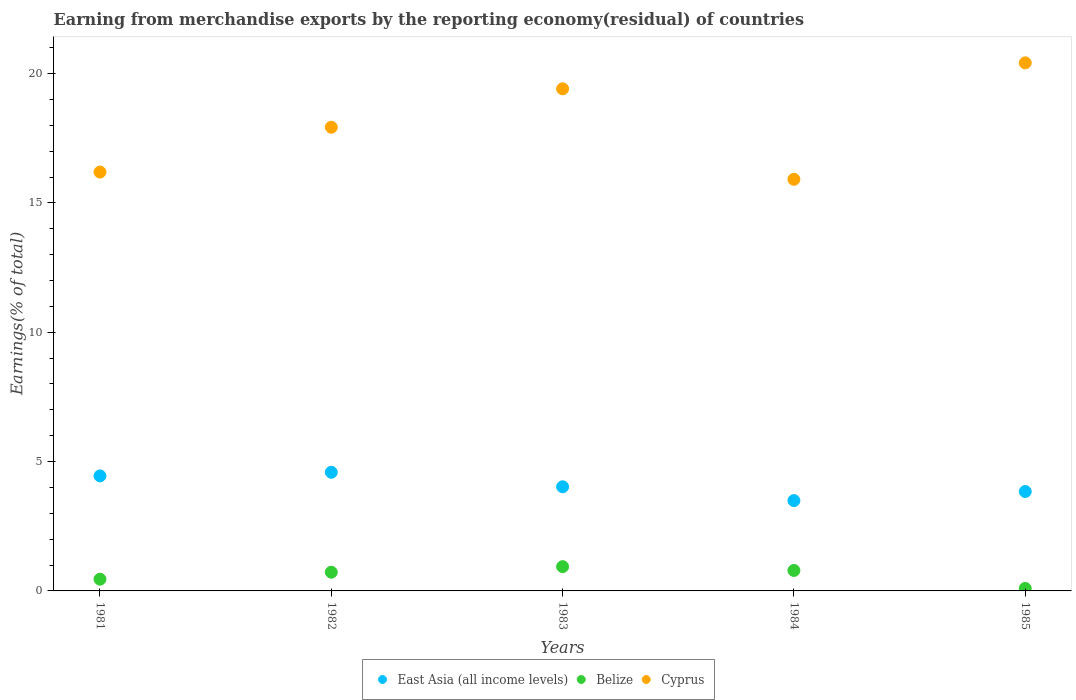How many different coloured dotlines are there?
Ensure brevity in your answer.  3. What is the percentage of amount earned from merchandise exports in East Asia (all income levels) in 1981?
Your answer should be compact. 4.45. Across all years, what is the maximum percentage of amount earned from merchandise exports in East Asia (all income levels)?
Offer a very short reply. 4.59. Across all years, what is the minimum percentage of amount earned from merchandise exports in East Asia (all income levels)?
Keep it short and to the point. 3.49. What is the total percentage of amount earned from merchandise exports in East Asia (all income levels) in the graph?
Give a very brief answer. 20.39. What is the difference between the percentage of amount earned from merchandise exports in Belize in 1981 and that in 1984?
Provide a short and direct response. -0.34. What is the difference between the percentage of amount earned from merchandise exports in East Asia (all income levels) in 1981 and the percentage of amount earned from merchandise exports in Cyprus in 1982?
Keep it short and to the point. -13.48. What is the average percentage of amount earned from merchandise exports in East Asia (all income levels) per year?
Give a very brief answer. 4.08. In the year 1985, what is the difference between the percentage of amount earned from merchandise exports in Belize and percentage of amount earned from merchandise exports in East Asia (all income levels)?
Keep it short and to the point. -3.75. In how many years, is the percentage of amount earned from merchandise exports in Belize greater than 16 %?
Offer a very short reply. 0. What is the ratio of the percentage of amount earned from merchandise exports in East Asia (all income levels) in 1982 to that in 1984?
Ensure brevity in your answer.  1.31. What is the difference between the highest and the second highest percentage of amount earned from merchandise exports in Belize?
Provide a short and direct response. 0.15. What is the difference between the highest and the lowest percentage of amount earned from merchandise exports in Cyprus?
Ensure brevity in your answer.  4.5. Is the sum of the percentage of amount earned from merchandise exports in East Asia (all income levels) in 1982 and 1985 greater than the maximum percentage of amount earned from merchandise exports in Cyprus across all years?
Offer a terse response. No. Is the percentage of amount earned from merchandise exports in East Asia (all income levels) strictly greater than the percentage of amount earned from merchandise exports in Belize over the years?
Your answer should be very brief. Yes. How many dotlines are there?
Your answer should be compact. 3. How many years are there in the graph?
Provide a succinct answer. 5. What is the difference between two consecutive major ticks on the Y-axis?
Offer a terse response. 5. Does the graph contain any zero values?
Your answer should be compact. No. Where does the legend appear in the graph?
Your response must be concise. Bottom center. How many legend labels are there?
Your answer should be compact. 3. How are the legend labels stacked?
Ensure brevity in your answer.  Horizontal. What is the title of the graph?
Provide a succinct answer. Earning from merchandise exports by the reporting economy(residual) of countries. Does "Peru" appear as one of the legend labels in the graph?
Make the answer very short. No. What is the label or title of the Y-axis?
Make the answer very short. Earnings(% of total). What is the Earnings(% of total) of East Asia (all income levels) in 1981?
Provide a succinct answer. 4.45. What is the Earnings(% of total) of Belize in 1981?
Your answer should be very brief. 0.45. What is the Earnings(% of total) of Cyprus in 1981?
Your answer should be very brief. 16.19. What is the Earnings(% of total) of East Asia (all income levels) in 1982?
Your response must be concise. 4.59. What is the Earnings(% of total) in Belize in 1982?
Your response must be concise. 0.72. What is the Earnings(% of total) in Cyprus in 1982?
Provide a succinct answer. 17.93. What is the Earnings(% of total) in East Asia (all income levels) in 1983?
Make the answer very short. 4.03. What is the Earnings(% of total) in Belize in 1983?
Make the answer very short. 0.94. What is the Earnings(% of total) in Cyprus in 1983?
Give a very brief answer. 19.41. What is the Earnings(% of total) in East Asia (all income levels) in 1984?
Provide a short and direct response. 3.49. What is the Earnings(% of total) of Belize in 1984?
Keep it short and to the point. 0.79. What is the Earnings(% of total) in Cyprus in 1984?
Offer a terse response. 15.91. What is the Earnings(% of total) of East Asia (all income levels) in 1985?
Provide a succinct answer. 3.84. What is the Earnings(% of total) in Belize in 1985?
Ensure brevity in your answer.  0.1. What is the Earnings(% of total) in Cyprus in 1985?
Your response must be concise. 20.41. Across all years, what is the maximum Earnings(% of total) of East Asia (all income levels)?
Provide a succinct answer. 4.59. Across all years, what is the maximum Earnings(% of total) of Belize?
Make the answer very short. 0.94. Across all years, what is the maximum Earnings(% of total) in Cyprus?
Keep it short and to the point. 20.41. Across all years, what is the minimum Earnings(% of total) in East Asia (all income levels)?
Your response must be concise. 3.49. Across all years, what is the minimum Earnings(% of total) of Belize?
Offer a terse response. 0.1. Across all years, what is the minimum Earnings(% of total) in Cyprus?
Provide a succinct answer. 15.91. What is the total Earnings(% of total) of East Asia (all income levels) in the graph?
Give a very brief answer. 20.39. What is the total Earnings(% of total) in Belize in the graph?
Your answer should be very brief. 3. What is the total Earnings(% of total) of Cyprus in the graph?
Keep it short and to the point. 89.86. What is the difference between the Earnings(% of total) in East Asia (all income levels) in 1981 and that in 1982?
Give a very brief answer. -0.14. What is the difference between the Earnings(% of total) of Belize in 1981 and that in 1982?
Provide a short and direct response. -0.27. What is the difference between the Earnings(% of total) in Cyprus in 1981 and that in 1982?
Your answer should be very brief. -1.73. What is the difference between the Earnings(% of total) in East Asia (all income levels) in 1981 and that in 1983?
Make the answer very short. 0.42. What is the difference between the Earnings(% of total) of Belize in 1981 and that in 1983?
Your answer should be compact. -0.48. What is the difference between the Earnings(% of total) in Cyprus in 1981 and that in 1983?
Provide a succinct answer. -3.22. What is the difference between the Earnings(% of total) of East Asia (all income levels) in 1981 and that in 1984?
Your response must be concise. 0.96. What is the difference between the Earnings(% of total) in Belize in 1981 and that in 1984?
Your answer should be compact. -0.34. What is the difference between the Earnings(% of total) in Cyprus in 1981 and that in 1984?
Your answer should be compact. 0.28. What is the difference between the Earnings(% of total) of East Asia (all income levels) in 1981 and that in 1985?
Your answer should be very brief. 0.6. What is the difference between the Earnings(% of total) of Belize in 1981 and that in 1985?
Provide a short and direct response. 0.36. What is the difference between the Earnings(% of total) of Cyprus in 1981 and that in 1985?
Offer a terse response. -4.22. What is the difference between the Earnings(% of total) in East Asia (all income levels) in 1982 and that in 1983?
Your response must be concise. 0.56. What is the difference between the Earnings(% of total) in Belize in 1982 and that in 1983?
Provide a succinct answer. -0.21. What is the difference between the Earnings(% of total) of Cyprus in 1982 and that in 1983?
Your answer should be very brief. -1.49. What is the difference between the Earnings(% of total) in East Asia (all income levels) in 1982 and that in 1984?
Your response must be concise. 1.09. What is the difference between the Earnings(% of total) of Belize in 1982 and that in 1984?
Give a very brief answer. -0.07. What is the difference between the Earnings(% of total) in Cyprus in 1982 and that in 1984?
Give a very brief answer. 2.01. What is the difference between the Earnings(% of total) in East Asia (all income levels) in 1982 and that in 1985?
Ensure brevity in your answer.  0.74. What is the difference between the Earnings(% of total) of Belize in 1982 and that in 1985?
Provide a short and direct response. 0.63. What is the difference between the Earnings(% of total) of Cyprus in 1982 and that in 1985?
Give a very brief answer. -2.49. What is the difference between the Earnings(% of total) in East Asia (all income levels) in 1983 and that in 1984?
Provide a succinct answer. 0.53. What is the difference between the Earnings(% of total) in Belize in 1983 and that in 1984?
Your answer should be compact. 0.15. What is the difference between the Earnings(% of total) of Cyprus in 1983 and that in 1984?
Provide a succinct answer. 3.5. What is the difference between the Earnings(% of total) in East Asia (all income levels) in 1983 and that in 1985?
Ensure brevity in your answer.  0.18. What is the difference between the Earnings(% of total) of Belize in 1983 and that in 1985?
Your answer should be very brief. 0.84. What is the difference between the Earnings(% of total) in Cyprus in 1983 and that in 1985?
Offer a terse response. -1. What is the difference between the Earnings(% of total) of East Asia (all income levels) in 1984 and that in 1985?
Provide a succinct answer. -0.35. What is the difference between the Earnings(% of total) of Belize in 1984 and that in 1985?
Offer a terse response. 0.69. What is the difference between the Earnings(% of total) in Cyprus in 1984 and that in 1985?
Offer a very short reply. -4.5. What is the difference between the Earnings(% of total) in East Asia (all income levels) in 1981 and the Earnings(% of total) in Belize in 1982?
Provide a succinct answer. 3.72. What is the difference between the Earnings(% of total) in East Asia (all income levels) in 1981 and the Earnings(% of total) in Cyprus in 1982?
Your response must be concise. -13.48. What is the difference between the Earnings(% of total) in Belize in 1981 and the Earnings(% of total) in Cyprus in 1982?
Provide a short and direct response. -17.47. What is the difference between the Earnings(% of total) of East Asia (all income levels) in 1981 and the Earnings(% of total) of Belize in 1983?
Give a very brief answer. 3.51. What is the difference between the Earnings(% of total) of East Asia (all income levels) in 1981 and the Earnings(% of total) of Cyprus in 1983?
Your response must be concise. -14.96. What is the difference between the Earnings(% of total) in Belize in 1981 and the Earnings(% of total) in Cyprus in 1983?
Your answer should be very brief. -18.96. What is the difference between the Earnings(% of total) in East Asia (all income levels) in 1981 and the Earnings(% of total) in Belize in 1984?
Offer a terse response. 3.66. What is the difference between the Earnings(% of total) of East Asia (all income levels) in 1981 and the Earnings(% of total) of Cyprus in 1984?
Give a very brief answer. -11.47. What is the difference between the Earnings(% of total) in Belize in 1981 and the Earnings(% of total) in Cyprus in 1984?
Offer a very short reply. -15.46. What is the difference between the Earnings(% of total) of East Asia (all income levels) in 1981 and the Earnings(% of total) of Belize in 1985?
Your answer should be very brief. 4.35. What is the difference between the Earnings(% of total) of East Asia (all income levels) in 1981 and the Earnings(% of total) of Cyprus in 1985?
Your answer should be very brief. -15.97. What is the difference between the Earnings(% of total) in Belize in 1981 and the Earnings(% of total) in Cyprus in 1985?
Give a very brief answer. -19.96. What is the difference between the Earnings(% of total) of East Asia (all income levels) in 1982 and the Earnings(% of total) of Belize in 1983?
Offer a very short reply. 3.65. What is the difference between the Earnings(% of total) in East Asia (all income levels) in 1982 and the Earnings(% of total) in Cyprus in 1983?
Offer a very short reply. -14.82. What is the difference between the Earnings(% of total) in Belize in 1982 and the Earnings(% of total) in Cyprus in 1983?
Your response must be concise. -18.69. What is the difference between the Earnings(% of total) of East Asia (all income levels) in 1982 and the Earnings(% of total) of Belize in 1984?
Make the answer very short. 3.8. What is the difference between the Earnings(% of total) in East Asia (all income levels) in 1982 and the Earnings(% of total) in Cyprus in 1984?
Offer a terse response. -11.33. What is the difference between the Earnings(% of total) of Belize in 1982 and the Earnings(% of total) of Cyprus in 1984?
Provide a succinct answer. -15.19. What is the difference between the Earnings(% of total) in East Asia (all income levels) in 1982 and the Earnings(% of total) in Belize in 1985?
Offer a very short reply. 4.49. What is the difference between the Earnings(% of total) in East Asia (all income levels) in 1982 and the Earnings(% of total) in Cyprus in 1985?
Ensure brevity in your answer.  -15.83. What is the difference between the Earnings(% of total) of Belize in 1982 and the Earnings(% of total) of Cyprus in 1985?
Keep it short and to the point. -19.69. What is the difference between the Earnings(% of total) of East Asia (all income levels) in 1983 and the Earnings(% of total) of Belize in 1984?
Offer a terse response. 3.23. What is the difference between the Earnings(% of total) in East Asia (all income levels) in 1983 and the Earnings(% of total) in Cyprus in 1984?
Your answer should be very brief. -11.89. What is the difference between the Earnings(% of total) of Belize in 1983 and the Earnings(% of total) of Cyprus in 1984?
Your answer should be compact. -14.97. What is the difference between the Earnings(% of total) in East Asia (all income levels) in 1983 and the Earnings(% of total) in Belize in 1985?
Provide a succinct answer. 3.93. What is the difference between the Earnings(% of total) of East Asia (all income levels) in 1983 and the Earnings(% of total) of Cyprus in 1985?
Your response must be concise. -16.39. What is the difference between the Earnings(% of total) in Belize in 1983 and the Earnings(% of total) in Cyprus in 1985?
Your answer should be very brief. -19.48. What is the difference between the Earnings(% of total) in East Asia (all income levels) in 1984 and the Earnings(% of total) in Belize in 1985?
Your response must be concise. 3.39. What is the difference between the Earnings(% of total) of East Asia (all income levels) in 1984 and the Earnings(% of total) of Cyprus in 1985?
Keep it short and to the point. -16.92. What is the difference between the Earnings(% of total) of Belize in 1984 and the Earnings(% of total) of Cyprus in 1985?
Your response must be concise. -19.62. What is the average Earnings(% of total) of East Asia (all income levels) per year?
Keep it short and to the point. 4.08. What is the average Earnings(% of total) in Belize per year?
Make the answer very short. 0.6. What is the average Earnings(% of total) of Cyprus per year?
Provide a short and direct response. 17.97. In the year 1981, what is the difference between the Earnings(% of total) of East Asia (all income levels) and Earnings(% of total) of Belize?
Provide a succinct answer. 3.99. In the year 1981, what is the difference between the Earnings(% of total) of East Asia (all income levels) and Earnings(% of total) of Cyprus?
Ensure brevity in your answer.  -11.75. In the year 1981, what is the difference between the Earnings(% of total) in Belize and Earnings(% of total) in Cyprus?
Make the answer very short. -15.74. In the year 1982, what is the difference between the Earnings(% of total) of East Asia (all income levels) and Earnings(% of total) of Belize?
Offer a very short reply. 3.86. In the year 1982, what is the difference between the Earnings(% of total) of East Asia (all income levels) and Earnings(% of total) of Cyprus?
Provide a succinct answer. -13.34. In the year 1982, what is the difference between the Earnings(% of total) of Belize and Earnings(% of total) of Cyprus?
Give a very brief answer. -17.2. In the year 1983, what is the difference between the Earnings(% of total) of East Asia (all income levels) and Earnings(% of total) of Belize?
Ensure brevity in your answer.  3.09. In the year 1983, what is the difference between the Earnings(% of total) in East Asia (all income levels) and Earnings(% of total) in Cyprus?
Provide a succinct answer. -15.39. In the year 1983, what is the difference between the Earnings(% of total) of Belize and Earnings(% of total) of Cyprus?
Your answer should be compact. -18.47. In the year 1984, what is the difference between the Earnings(% of total) of East Asia (all income levels) and Earnings(% of total) of Belize?
Ensure brevity in your answer.  2.7. In the year 1984, what is the difference between the Earnings(% of total) in East Asia (all income levels) and Earnings(% of total) in Cyprus?
Provide a succinct answer. -12.42. In the year 1984, what is the difference between the Earnings(% of total) of Belize and Earnings(% of total) of Cyprus?
Offer a terse response. -15.12. In the year 1985, what is the difference between the Earnings(% of total) of East Asia (all income levels) and Earnings(% of total) of Belize?
Keep it short and to the point. 3.75. In the year 1985, what is the difference between the Earnings(% of total) in East Asia (all income levels) and Earnings(% of total) in Cyprus?
Offer a very short reply. -16.57. In the year 1985, what is the difference between the Earnings(% of total) of Belize and Earnings(% of total) of Cyprus?
Keep it short and to the point. -20.32. What is the ratio of the Earnings(% of total) of East Asia (all income levels) in 1981 to that in 1982?
Make the answer very short. 0.97. What is the ratio of the Earnings(% of total) of Belize in 1981 to that in 1982?
Provide a short and direct response. 0.63. What is the ratio of the Earnings(% of total) in Cyprus in 1981 to that in 1982?
Your answer should be compact. 0.9. What is the ratio of the Earnings(% of total) of East Asia (all income levels) in 1981 to that in 1983?
Keep it short and to the point. 1.1. What is the ratio of the Earnings(% of total) in Belize in 1981 to that in 1983?
Your answer should be compact. 0.48. What is the ratio of the Earnings(% of total) in Cyprus in 1981 to that in 1983?
Offer a very short reply. 0.83. What is the ratio of the Earnings(% of total) of East Asia (all income levels) in 1981 to that in 1984?
Your answer should be compact. 1.27. What is the ratio of the Earnings(% of total) in Belize in 1981 to that in 1984?
Give a very brief answer. 0.57. What is the ratio of the Earnings(% of total) of Cyprus in 1981 to that in 1984?
Your answer should be compact. 1.02. What is the ratio of the Earnings(% of total) in East Asia (all income levels) in 1981 to that in 1985?
Ensure brevity in your answer.  1.16. What is the ratio of the Earnings(% of total) of Belize in 1981 to that in 1985?
Ensure brevity in your answer.  4.69. What is the ratio of the Earnings(% of total) in Cyprus in 1981 to that in 1985?
Keep it short and to the point. 0.79. What is the ratio of the Earnings(% of total) of East Asia (all income levels) in 1982 to that in 1983?
Keep it short and to the point. 1.14. What is the ratio of the Earnings(% of total) in Belize in 1982 to that in 1983?
Make the answer very short. 0.77. What is the ratio of the Earnings(% of total) in Cyprus in 1982 to that in 1983?
Ensure brevity in your answer.  0.92. What is the ratio of the Earnings(% of total) of East Asia (all income levels) in 1982 to that in 1984?
Make the answer very short. 1.31. What is the ratio of the Earnings(% of total) of Belize in 1982 to that in 1984?
Make the answer very short. 0.91. What is the ratio of the Earnings(% of total) in Cyprus in 1982 to that in 1984?
Make the answer very short. 1.13. What is the ratio of the Earnings(% of total) of East Asia (all income levels) in 1982 to that in 1985?
Your answer should be very brief. 1.19. What is the ratio of the Earnings(% of total) of Belize in 1982 to that in 1985?
Give a very brief answer. 7.49. What is the ratio of the Earnings(% of total) of Cyprus in 1982 to that in 1985?
Give a very brief answer. 0.88. What is the ratio of the Earnings(% of total) in East Asia (all income levels) in 1983 to that in 1984?
Your answer should be compact. 1.15. What is the ratio of the Earnings(% of total) of Belize in 1983 to that in 1984?
Offer a very short reply. 1.19. What is the ratio of the Earnings(% of total) in Cyprus in 1983 to that in 1984?
Ensure brevity in your answer.  1.22. What is the ratio of the Earnings(% of total) of East Asia (all income levels) in 1983 to that in 1985?
Give a very brief answer. 1.05. What is the ratio of the Earnings(% of total) in Belize in 1983 to that in 1985?
Provide a short and direct response. 9.72. What is the ratio of the Earnings(% of total) of Cyprus in 1983 to that in 1985?
Provide a succinct answer. 0.95. What is the ratio of the Earnings(% of total) in East Asia (all income levels) in 1984 to that in 1985?
Ensure brevity in your answer.  0.91. What is the ratio of the Earnings(% of total) of Belize in 1984 to that in 1985?
Offer a terse response. 8.19. What is the ratio of the Earnings(% of total) of Cyprus in 1984 to that in 1985?
Keep it short and to the point. 0.78. What is the difference between the highest and the second highest Earnings(% of total) of East Asia (all income levels)?
Ensure brevity in your answer.  0.14. What is the difference between the highest and the second highest Earnings(% of total) of Belize?
Provide a succinct answer. 0.15. What is the difference between the highest and the second highest Earnings(% of total) in Cyprus?
Offer a terse response. 1. What is the difference between the highest and the lowest Earnings(% of total) of East Asia (all income levels)?
Provide a short and direct response. 1.09. What is the difference between the highest and the lowest Earnings(% of total) in Belize?
Ensure brevity in your answer.  0.84. What is the difference between the highest and the lowest Earnings(% of total) of Cyprus?
Provide a succinct answer. 4.5. 